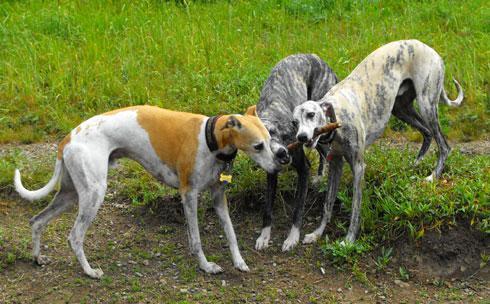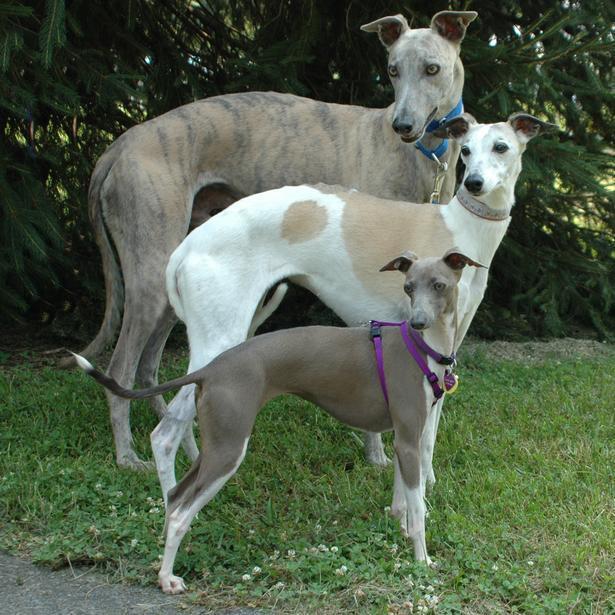The first image is the image on the left, the second image is the image on the right. Considering the images on both sides, is "The right image contains at least two dogs." valid? Answer yes or no. Yes. The first image is the image on the left, the second image is the image on the right. Evaluate the accuracy of this statement regarding the images: "At least one image shows a tan dog with a white chest standing on grass, facing leftward.". Is it true? Answer yes or no. No. 